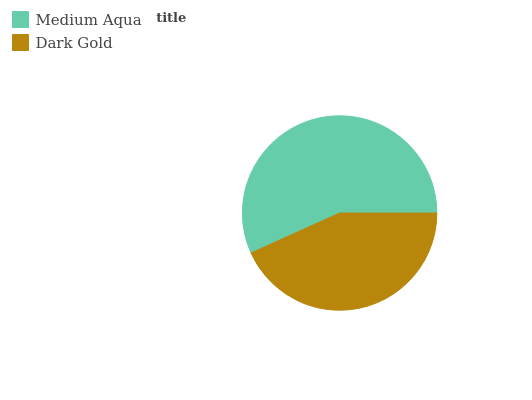Is Dark Gold the minimum?
Answer yes or no. Yes. Is Medium Aqua the maximum?
Answer yes or no. Yes. Is Dark Gold the maximum?
Answer yes or no. No. Is Medium Aqua greater than Dark Gold?
Answer yes or no. Yes. Is Dark Gold less than Medium Aqua?
Answer yes or no. Yes. Is Dark Gold greater than Medium Aqua?
Answer yes or no. No. Is Medium Aqua less than Dark Gold?
Answer yes or no. No. Is Medium Aqua the high median?
Answer yes or no. Yes. Is Dark Gold the low median?
Answer yes or no. Yes. Is Dark Gold the high median?
Answer yes or no. No. Is Medium Aqua the low median?
Answer yes or no. No. 